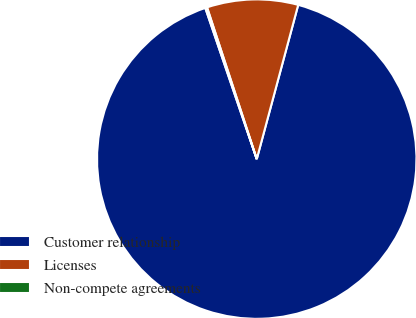Convert chart. <chart><loc_0><loc_0><loc_500><loc_500><pie_chart><fcel>Customer relationship<fcel>Licenses<fcel>Non-compete agreements<nl><fcel>90.6%<fcel>9.22%<fcel>0.18%<nl></chart> 